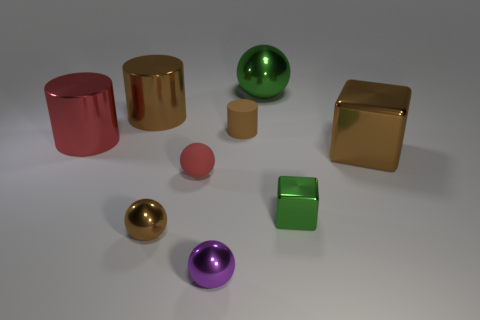There is a big shiny thing that is the same color as the small metallic cube; what is its shape?
Your answer should be compact. Sphere. Is the brown rubber cylinder the same size as the red sphere?
Your response must be concise. Yes. What material is the red thing that is on the right side of the brown cylinder that is behind the tiny brown cylinder made of?
Make the answer very short. Rubber. There is a matte object that is in front of the brown metallic block; does it have the same shape as the green shiny object that is behind the large brown metal cylinder?
Make the answer very short. Yes. Are there an equal number of metal things behind the brown metal ball and tiny brown metal spheres?
Ensure brevity in your answer.  No. Is there a small object behind the brown metallic ball that is in front of the big red cylinder?
Your response must be concise. Yes. Is there any other thing of the same color as the large sphere?
Offer a terse response. Yes. Does the green object that is behind the brown shiny cylinder have the same material as the large brown cube?
Provide a short and direct response. Yes. Is the number of large brown shiny cubes on the left side of the large brown cylinder the same as the number of big brown metallic blocks in front of the brown metallic cube?
Offer a very short reply. Yes. What is the size of the green object behind the big red object behind the green shiny cube?
Provide a succinct answer. Large. 